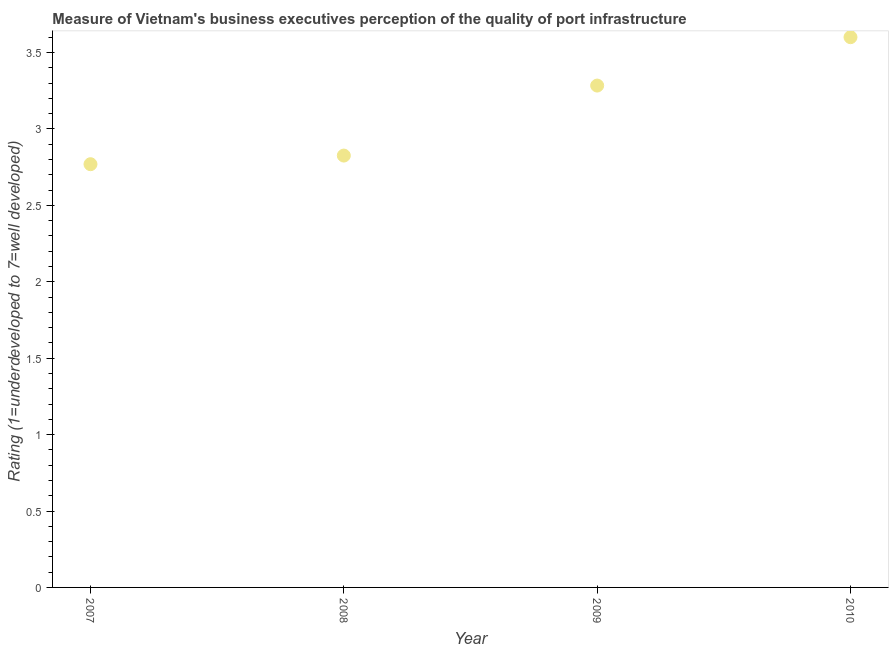What is the rating measuring quality of port infrastructure in 2007?
Keep it short and to the point. 2.77. Across all years, what is the maximum rating measuring quality of port infrastructure?
Provide a succinct answer. 3.6. Across all years, what is the minimum rating measuring quality of port infrastructure?
Make the answer very short. 2.77. In which year was the rating measuring quality of port infrastructure maximum?
Your answer should be very brief. 2010. What is the sum of the rating measuring quality of port infrastructure?
Provide a succinct answer. 12.48. What is the difference between the rating measuring quality of port infrastructure in 2008 and 2010?
Your answer should be compact. -0.77. What is the average rating measuring quality of port infrastructure per year?
Ensure brevity in your answer.  3.12. What is the median rating measuring quality of port infrastructure?
Provide a succinct answer. 3.05. In how many years, is the rating measuring quality of port infrastructure greater than 2.4 ?
Provide a short and direct response. 4. What is the ratio of the rating measuring quality of port infrastructure in 2009 to that in 2010?
Make the answer very short. 0.91. Is the rating measuring quality of port infrastructure in 2007 less than that in 2008?
Your answer should be compact. Yes. Is the difference between the rating measuring quality of port infrastructure in 2009 and 2010 greater than the difference between any two years?
Your answer should be very brief. No. What is the difference between the highest and the second highest rating measuring quality of port infrastructure?
Offer a very short reply. 0.32. Is the sum of the rating measuring quality of port infrastructure in 2007 and 2008 greater than the maximum rating measuring quality of port infrastructure across all years?
Offer a very short reply. Yes. What is the difference between the highest and the lowest rating measuring quality of port infrastructure?
Your response must be concise. 0.83. In how many years, is the rating measuring quality of port infrastructure greater than the average rating measuring quality of port infrastructure taken over all years?
Offer a terse response. 2. Does the rating measuring quality of port infrastructure monotonically increase over the years?
Provide a succinct answer. Yes. How many dotlines are there?
Ensure brevity in your answer.  1. How many years are there in the graph?
Your answer should be very brief. 4. What is the difference between two consecutive major ticks on the Y-axis?
Offer a very short reply. 0.5. Are the values on the major ticks of Y-axis written in scientific E-notation?
Offer a very short reply. No. Does the graph contain grids?
Ensure brevity in your answer.  No. What is the title of the graph?
Offer a terse response. Measure of Vietnam's business executives perception of the quality of port infrastructure. What is the label or title of the Y-axis?
Your answer should be very brief. Rating (1=underdeveloped to 7=well developed) . What is the Rating (1=underdeveloped to 7=well developed)  in 2007?
Your answer should be compact. 2.77. What is the Rating (1=underdeveloped to 7=well developed)  in 2008?
Offer a very short reply. 2.83. What is the Rating (1=underdeveloped to 7=well developed)  in 2009?
Offer a terse response. 3.28. What is the Rating (1=underdeveloped to 7=well developed)  in 2010?
Provide a short and direct response. 3.6. What is the difference between the Rating (1=underdeveloped to 7=well developed)  in 2007 and 2008?
Give a very brief answer. -0.06. What is the difference between the Rating (1=underdeveloped to 7=well developed)  in 2007 and 2009?
Offer a very short reply. -0.51. What is the difference between the Rating (1=underdeveloped to 7=well developed)  in 2007 and 2010?
Ensure brevity in your answer.  -0.83. What is the difference between the Rating (1=underdeveloped to 7=well developed)  in 2008 and 2009?
Keep it short and to the point. -0.46. What is the difference between the Rating (1=underdeveloped to 7=well developed)  in 2008 and 2010?
Offer a very short reply. -0.77. What is the difference between the Rating (1=underdeveloped to 7=well developed)  in 2009 and 2010?
Offer a very short reply. -0.32. What is the ratio of the Rating (1=underdeveloped to 7=well developed)  in 2007 to that in 2008?
Your answer should be compact. 0.98. What is the ratio of the Rating (1=underdeveloped to 7=well developed)  in 2007 to that in 2009?
Your answer should be compact. 0.84. What is the ratio of the Rating (1=underdeveloped to 7=well developed)  in 2007 to that in 2010?
Your answer should be compact. 0.77. What is the ratio of the Rating (1=underdeveloped to 7=well developed)  in 2008 to that in 2009?
Offer a very short reply. 0.86. What is the ratio of the Rating (1=underdeveloped to 7=well developed)  in 2008 to that in 2010?
Your response must be concise. 0.79. What is the ratio of the Rating (1=underdeveloped to 7=well developed)  in 2009 to that in 2010?
Offer a very short reply. 0.91. 